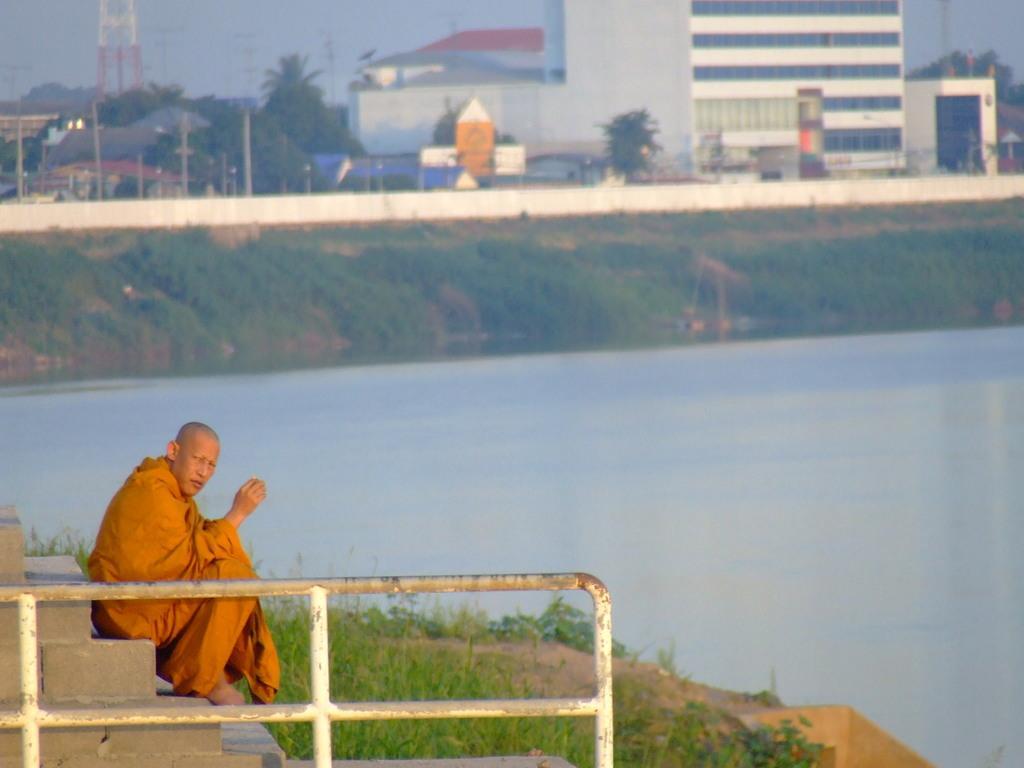Please provide a concise description of this image. The man in front of the picture wearing orange dress is sitting on the staircase. Beside that, we see a railing. In front of him, we see grass. Behind him, we see water. There are buildings, trees, tower and poles in the background. 